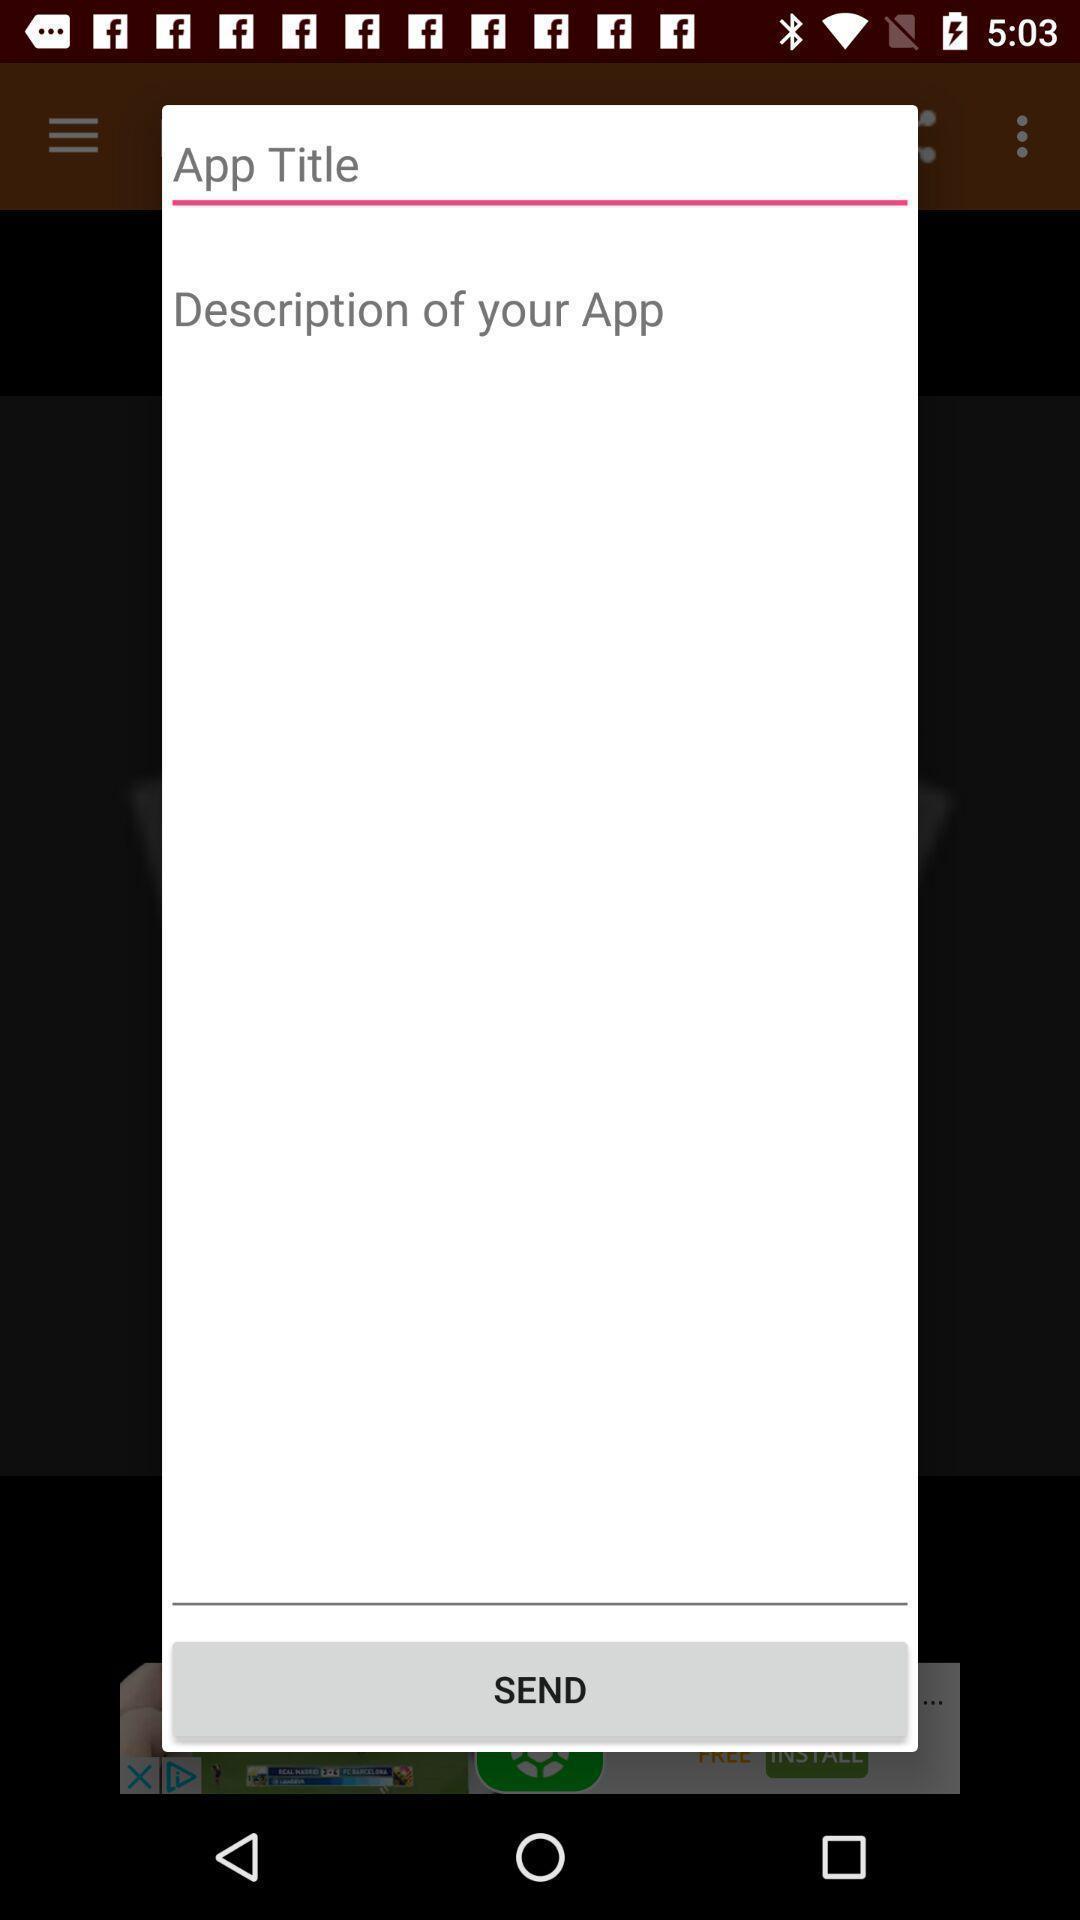What can you discern from this picture? Pop-up shows app title. 